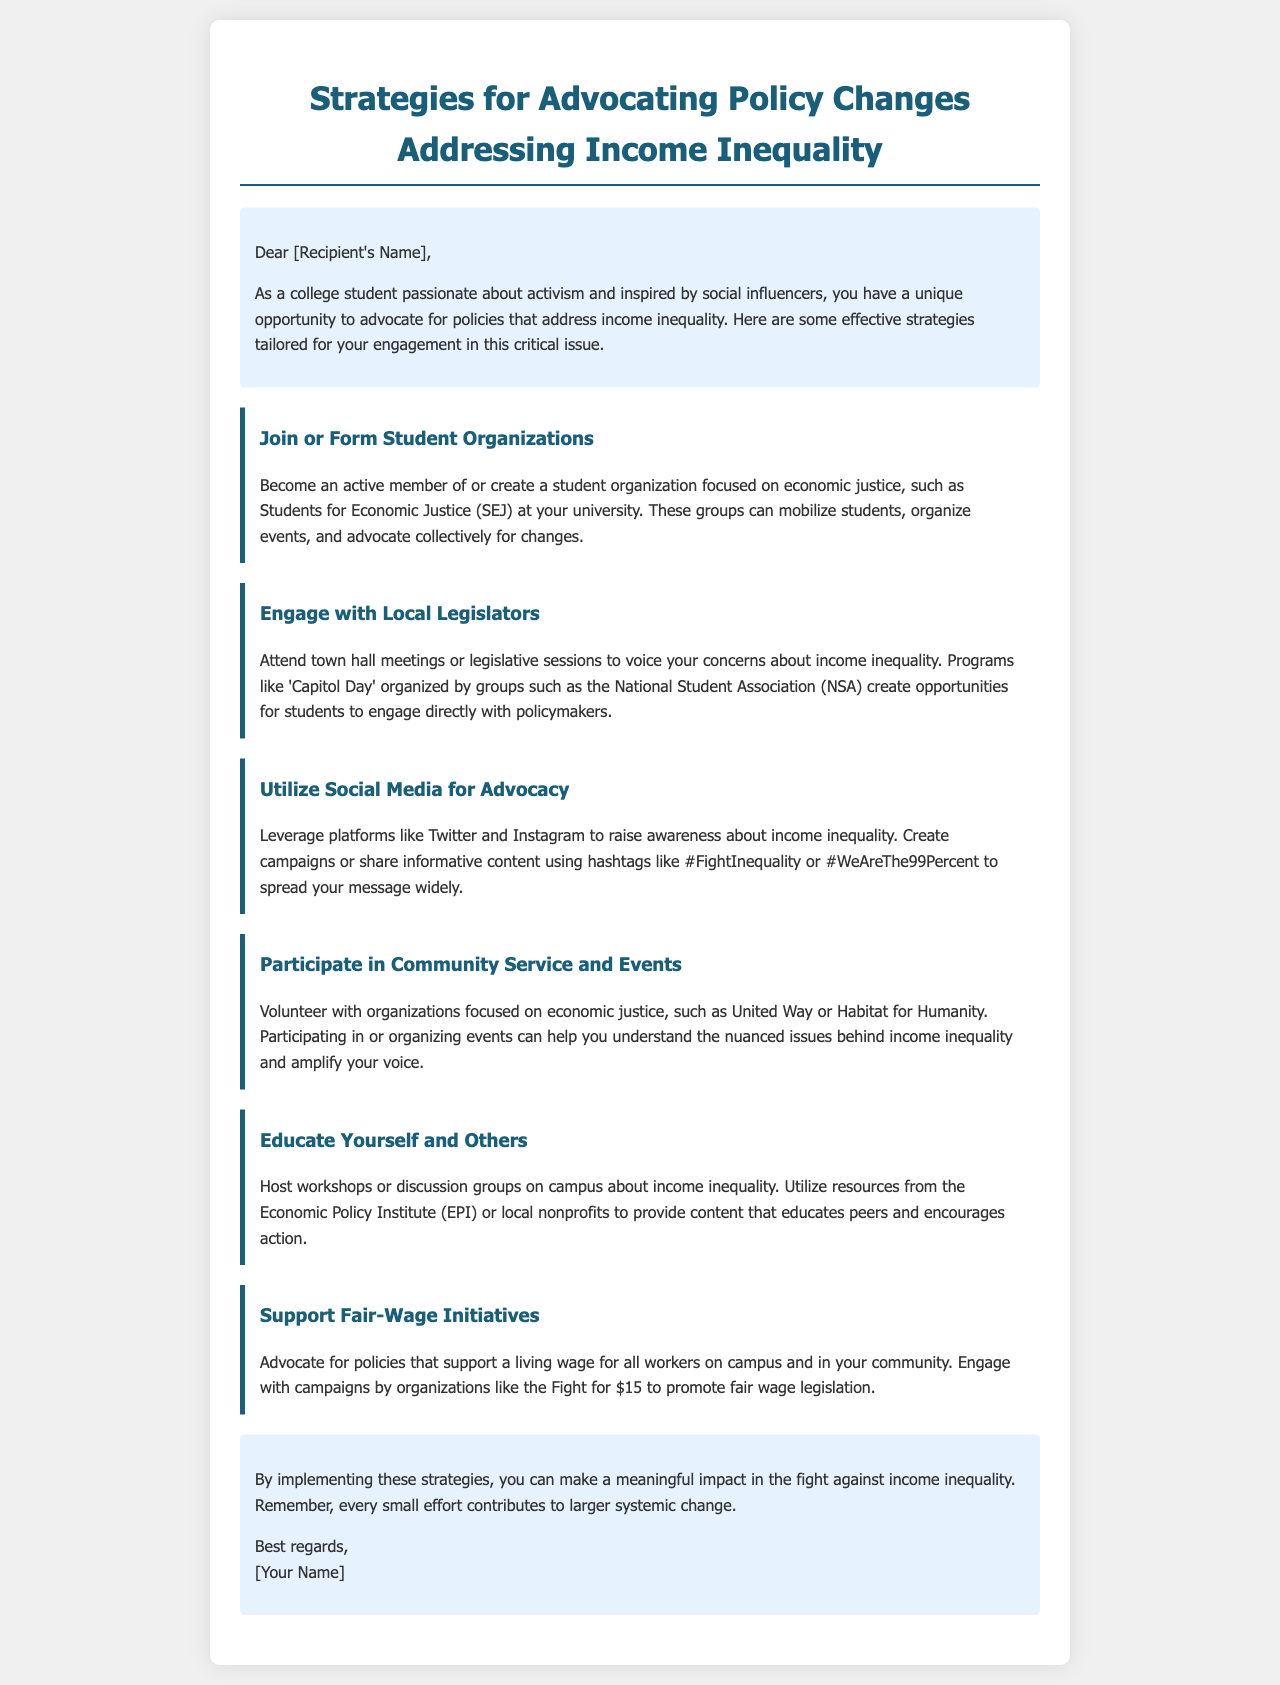What is the title of the document? The title is listed at the top of the document under the heading.
Answer: Strategies for Advocating Policy Changes Addressing Income Inequality Who can join or form student organizations? The document states that college students can participate in student organizations focused on economic justice.
Answer: College students What is one example of a student organization mentioned? An example is provided in the document for an organization focusing on economic justice.
Answer: Students for Economic Justice What is the name of the event that allows students to engage with policymakers? The document mentions a specific event for student engagement with legislators.
Answer: Capitol Day Which social media platforms are suggested for advocacy? The document refers to specific social media platforms for raising awareness.
Answer: Twitter and Instagram What is one community organization mentioned for volunteer opportunities? The document lists a community organization focused on economic justice.
Answer: United Way What initiative is promoted to support fair wages? The document highlights a campaign focused on fair wage legislation.
Answer: Fight for $15 How can students educate themselves and others according to the document? The document suggests a method for education on campus related to income inequality.
Answer: Host workshops or discussion groups What is the document’s conclusion about small efforts? The document summarizes the impact of small efforts toward systemic change.
Answer: Every small effort contributes to larger systemic change 